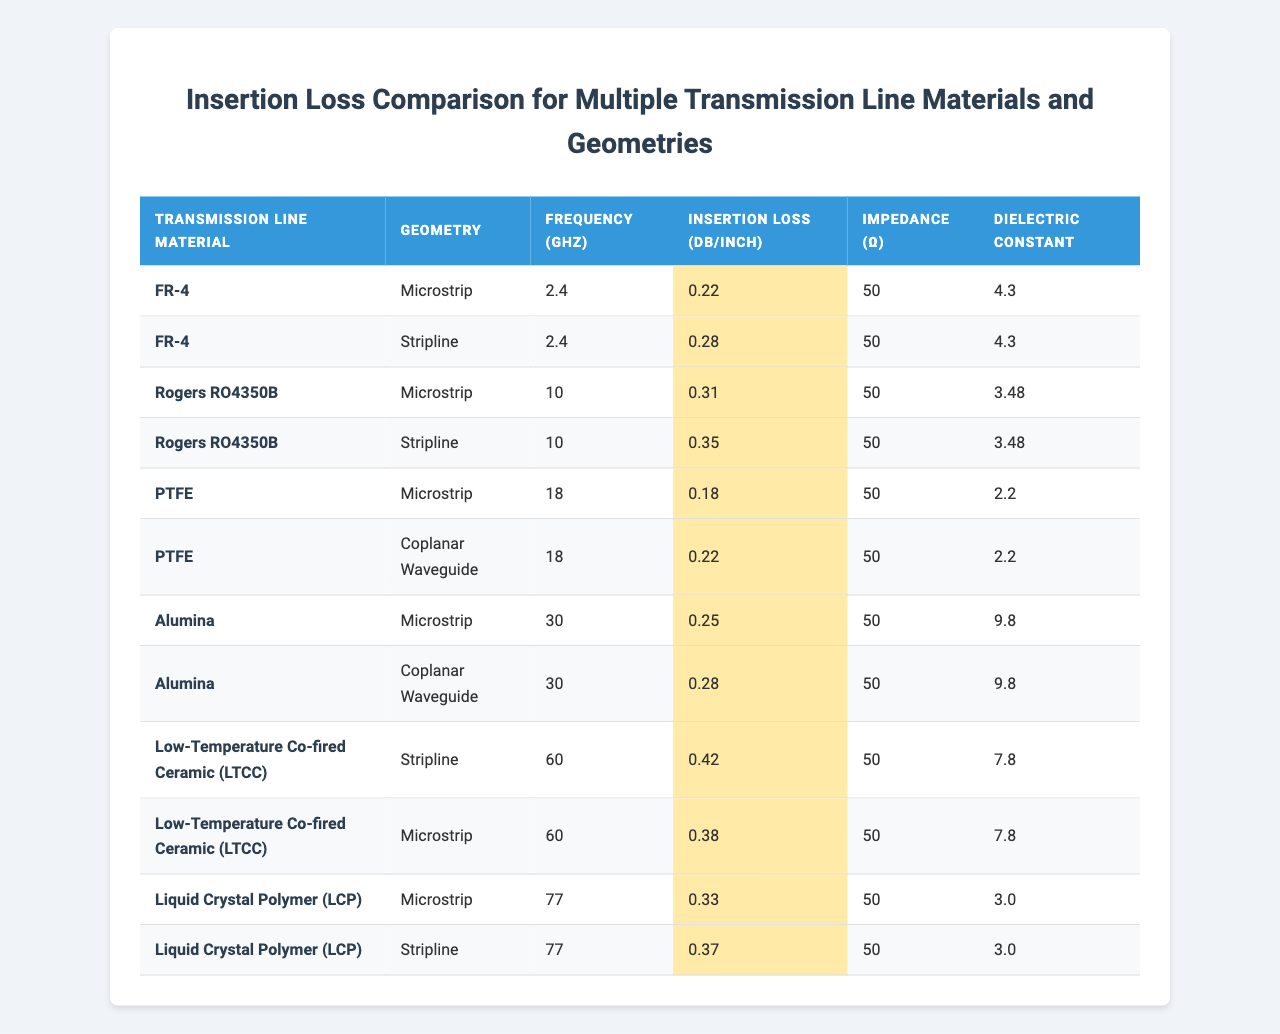What is the insertion loss for the PTFE Microstrip at 18 GHz? The table shows that the insertion loss for PTFE Microstrip at 18 GHz is 0.18 dB/inch.
Answer: 0.18 dB/inch Which material has the highest insertion loss in the Microstrip geometry? Comparing the insertion losses in the Microstrip geometry: FR-4 (0.22 dB/inch), Rogers RO4350B (0.31 dB/inch), PTFE (0.18 dB/inch), Alumina (0.25 dB/inch), and LCP (0.33 dB/inch); LCP has the highest at 0.33 dB/inch.
Answer: LCP What is the dielectric constant of Rogers RO4350B? The table lists the dielectric constant for Rogers RO4350B as 3.48.
Answer: 3.48 Which geometry has the lowest average insertion loss among the listed materials and frequencies? The Microstrip has insertion losses of 0.22, 0.31, 0.18, 0.25, and 0.33 dB/inch, averaging (0.22 + 0.31 + 0.18 + 0.25 + 0.33) / 5 = 0.257 dB/inch. The Coplanar Waveguide has insertion losses of 0.22 dB/inch (PTFE) and 0.28 dB/inch (Alumina), averaging (0.22 + 0.28) / 2 = 0.25 dB/inch, which is lower than Microstrip. The lowest therefore is Coplanar Waveguide with 0.25 dB/inch.
Answer: Coplanar Waveguide Is the insertion loss higher for Stripline or Microstrip at 2.4 GHz? At 2.4 GHz, the insertion loss for Microstrip is 0.22 dB/inch, while for Stripline it is 0.28 dB/inch; therefore, Stripline has higher insertion loss.
Answer: Yes What is the impedance for the Low-Temperature Co-fired Ceramic (LTCC) in Microstrip geometry? The table shows that the impedance for LTCC in Microstrip geometry is 50 Ω.
Answer: 50 Ω What is the difference in insertion loss between the Liquid Crystal Polymer (LCP) Microstrip and Stripline at 77 GHz? At 77 GHz, the insertion loss for LCP Microstrip is 0.33 dB/inch, and for LCP Stripline, it is 0.37 dB/inch. The difference is 0.37 - 0.33 = 0.04 dB/inch.
Answer: 0.04 dB/inch Which material with Microstrip geometry has the lowest dielectric constant? The table indicates the dielectric constants for the materials: FR-4 (4.3), Rogers RO4350B (3.48), PTFE (2.2), Alumina (9.8), LCP (3.0). PTFE has the lowest dielectric constant at 2.2.
Answer: PTFE If the insertion loss for PTFE Coplanar Waveguide is 0.22 dB/inch, how much less is it compared to the insertion loss of Low-Temperature Co-fired Ceramic (LTCC) Stripline at 60 GHz? The insertion loss for LTCC Stripline is 0.42 dB/inch; the difference is 0.42 - 0.22 = 0.20 dB/inch.
Answer: 0.20 dB/inch For which frequency does the Alumina Coplanar Waveguide have an insertion loss close to the PTFE Microstrip? The Alumina Coplanar Waveguide has an insertion loss of 0.28 dB/inch at 30 GHz, closely matching the PTFE Microstrip's 0.18 dB/inch at 18 GHz. Therefore, the closest frequency with a similar insertion loss is 30 GHz, given the difference.
Answer: 30 GHz Is there a material that has the same insertion loss in both Microstrip and Stripline geometries? The table shows that FR-4 has an insertion loss of 0.22 dB/inch in Microstrip and 0.28 dB/inch in Stripline; Rogers RO4350B has 0.31 (Microstrip) and 0.35 (Stripline), etc. None of the materials listed have the same insertion loss in both geometries.
Answer: No 